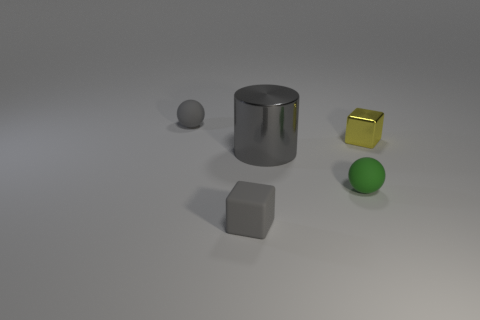There is a ball that is made of the same material as the tiny green object; what color is it?
Make the answer very short. Gray. What is the shape of the metallic object that is the same color as the tiny matte cube?
Make the answer very short. Cylinder. There is a metal thing to the right of the green rubber sphere; is it the same size as the gray matte thing behind the big gray object?
Provide a short and direct response. Yes. What number of cylinders are small purple matte things or yellow things?
Offer a very short reply. 0. Do the small gray object that is to the right of the gray rubber sphere and the small yellow object have the same material?
Make the answer very short. No. How many other things are the same size as the yellow cube?
Ensure brevity in your answer.  3. How many small objects are either yellow objects or green balls?
Your answer should be very brief. 2. Do the large shiny thing and the metal cube have the same color?
Offer a very short reply. No. Is the number of matte balls on the left side of the tiny gray matte ball greater than the number of large things that are to the right of the gray metallic object?
Keep it short and to the point. No. There is a tiny block that is to the left of the yellow metallic object; is it the same color as the big cylinder?
Keep it short and to the point. Yes. 